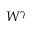<formula> <loc_0><loc_0><loc_500><loc_500>W ^ { \gamma }</formula> 